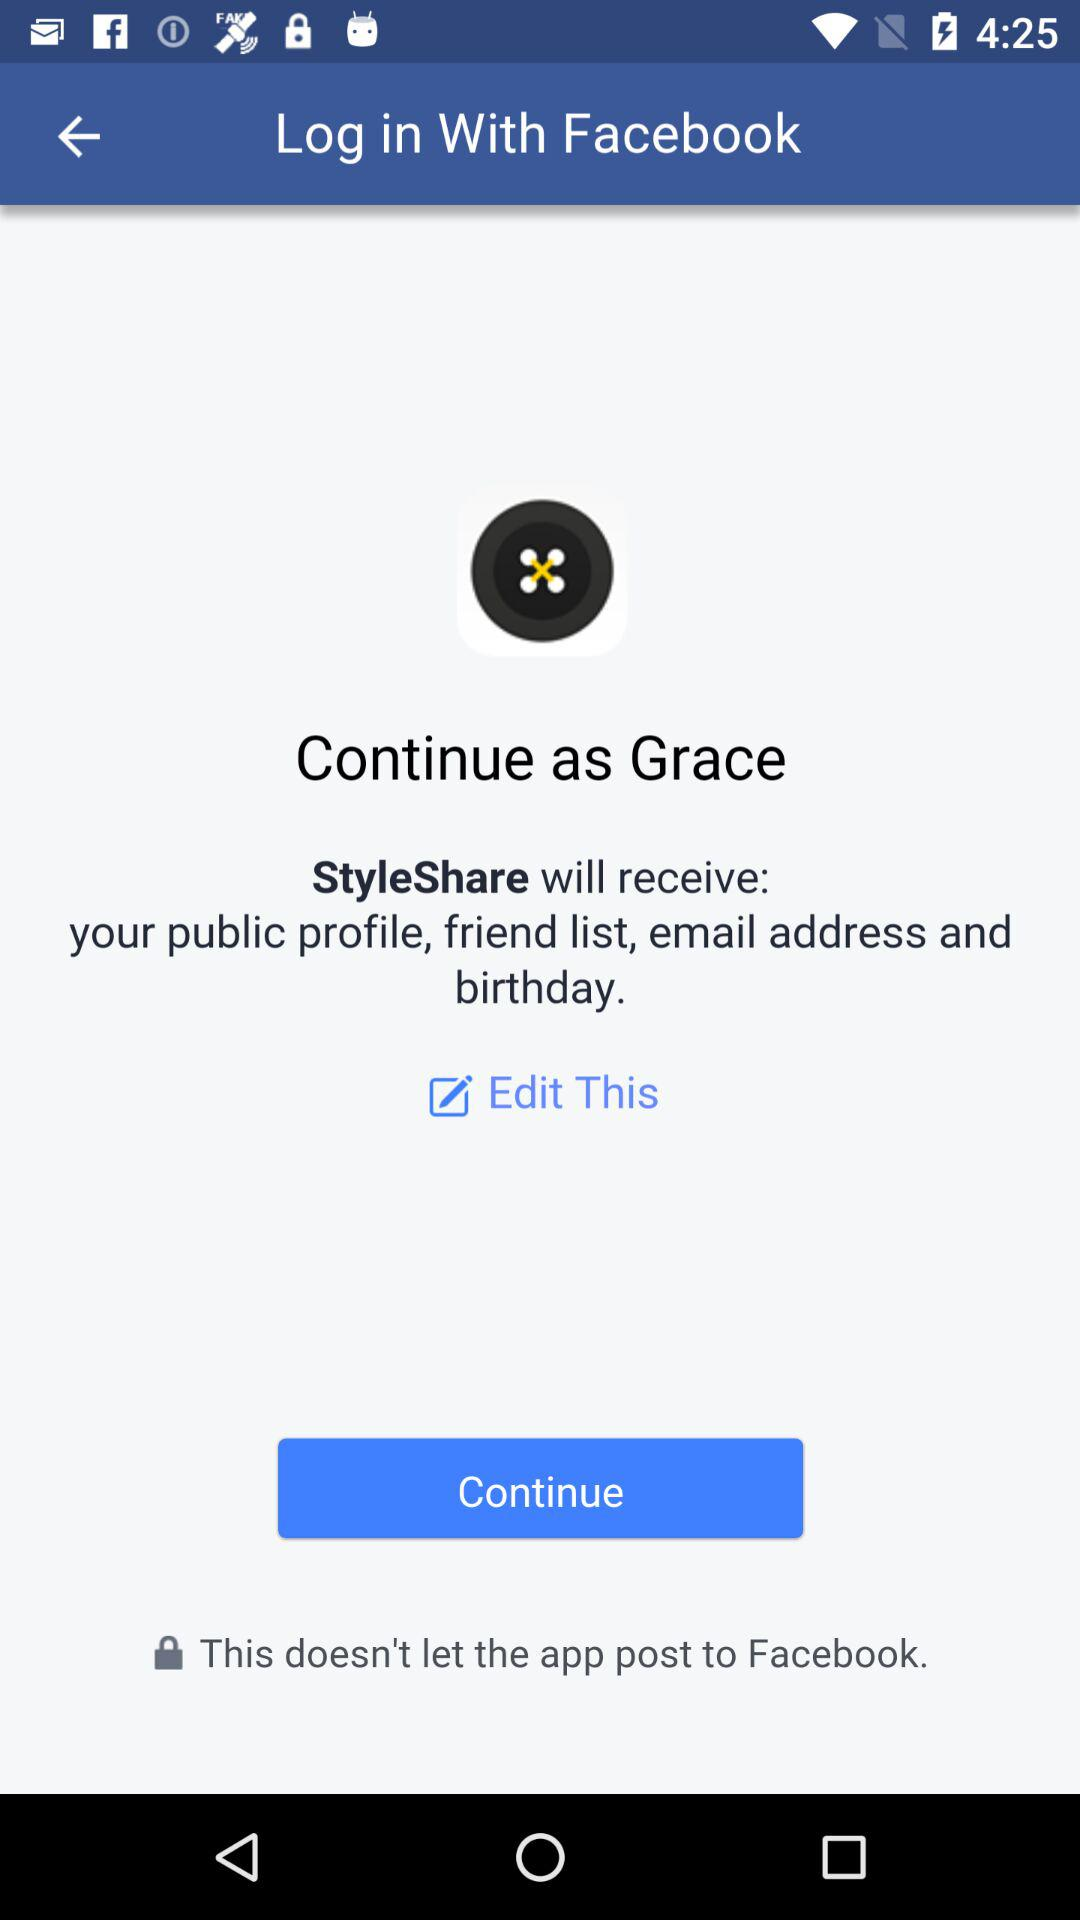What is the user name? The user name is Grace. 